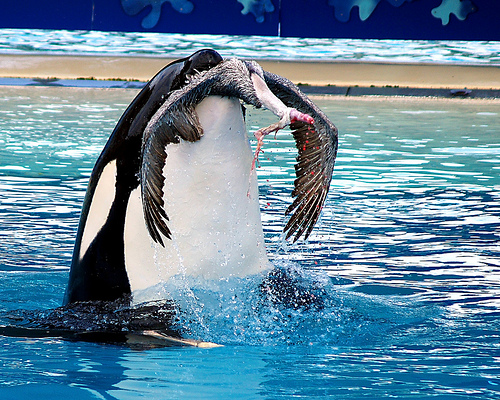<image>
Can you confirm if the bird is behind the orca? No. The bird is not behind the orca. From this viewpoint, the bird appears to be positioned elsewhere in the scene. Is the bird in the whale? Yes. The bird is contained within or inside the whale, showing a containment relationship. Where is the bird in relation to the water? Is it above the water? Yes. The bird is positioned above the water in the vertical space, higher up in the scene. 